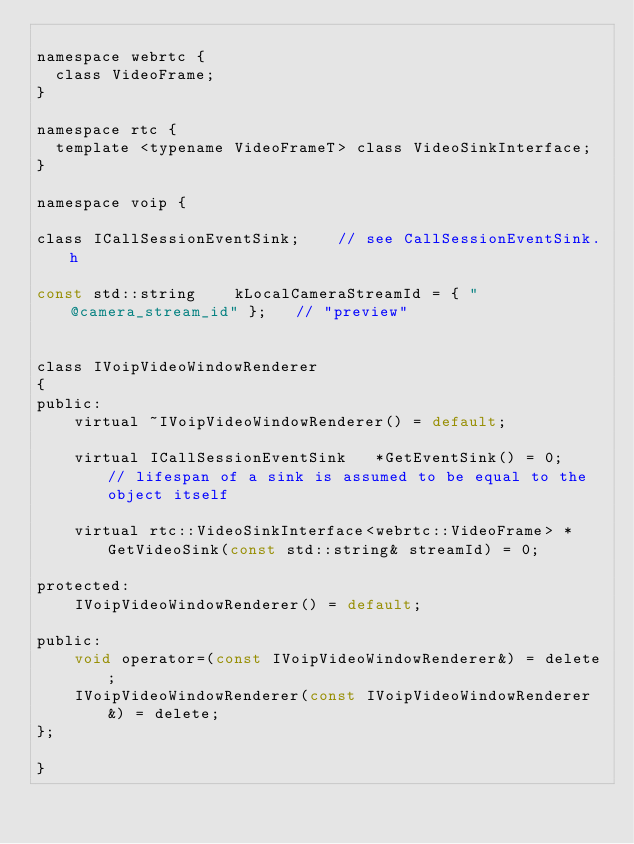<code> <loc_0><loc_0><loc_500><loc_500><_C_>
namespace webrtc {
  class VideoFrame;
}

namespace rtc {
  template <typename VideoFrameT> class VideoSinkInterface;
}

namespace voip {

class ICallSessionEventSink;    // see CallSessionEventSink.h

const std::string    kLocalCameraStreamId = { "@camera_stream_id" };   // "preview"


class IVoipVideoWindowRenderer
{
public:
    virtual ~IVoipVideoWindowRenderer() = default;

    virtual ICallSessionEventSink   *GetEventSink() = 0;    // lifespan of a sink is assumed to be equal to the object itself

    virtual rtc::VideoSinkInterface<webrtc::VideoFrame> *GetVideoSink(const std::string& streamId) = 0;

protected:
    IVoipVideoWindowRenderer() = default;

public:
    void operator=(const IVoipVideoWindowRenderer&) = delete;
    IVoipVideoWindowRenderer(const IVoipVideoWindowRenderer&) = delete;
};

}
</code> 